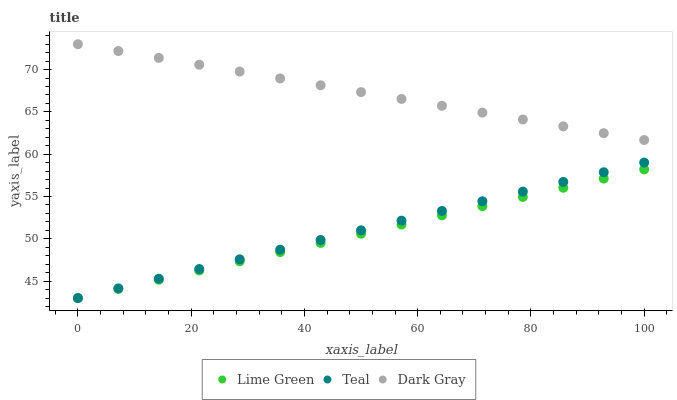Does Lime Green have the minimum area under the curve?
Answer yes or no. Yes. Does Dark Gray have the maximum area under the curve?
Answer yes or no. Yes. Does Teal have the minimum area under the curve?
Answer yes or no. No. Does Teal have the maximum area under the curve?
Answer yes or no. No. Is Lime Green the smoothest?
Answer yes or no. Yes. Is Teal the roughest?
Answer yes or no. Yes. Is Teal the smoothest?
Answer yes or no. No. Is Lime Green the roughest?
Answer yes or no. No. Does Lime Green have the lowest value?
Answer yes or no. Yes. Does Dark Gray have the highest value?
Answer yes or no. Yes. Does Teal have the highest value?
Answer yes or no. No. Is Lime Green less than Dark Gray?
Answer yes or no. Yes. Is Dark Gray greater than Teal?
Answer yes or no. Yes. Does Lime Green intersect Teal?
Answer yes or no. Yes. Is Lime Green less than Teal?
Answer yes or no. No. Is Lime Green greater than Teal?
Answer yes or no. No. Does Lime Green intersect Dark Gray?
Answer yes or no. No. 